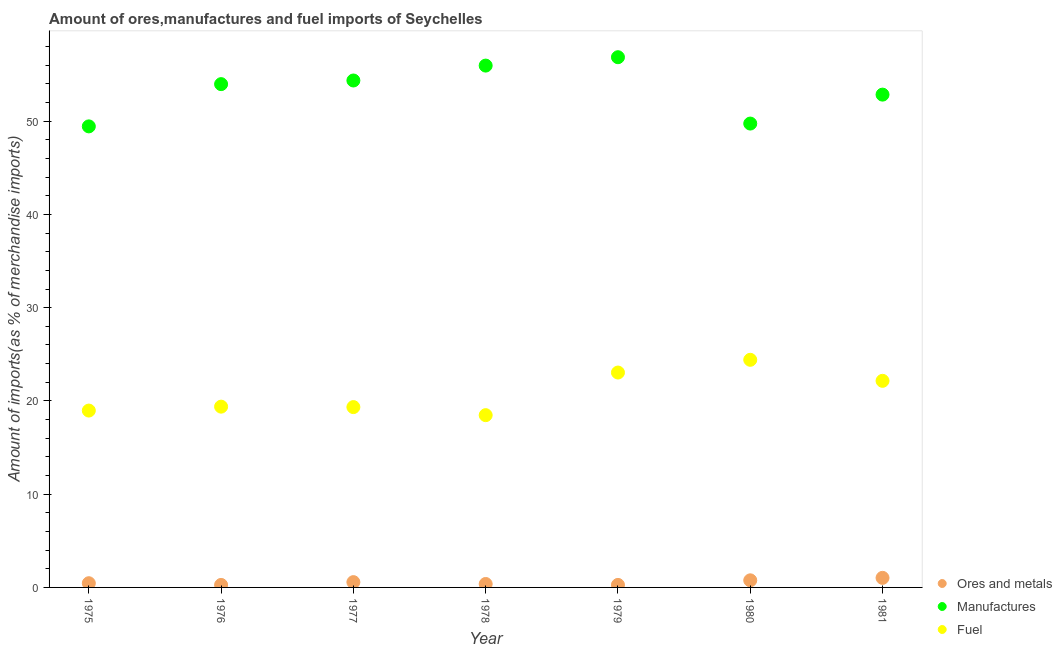What is the percentage of manufactures imports in 1976?
Ensure brevity in your answer.  53.97. Across all years, what is the maximum percentage of ores and metals imports?
Make the answer very short. 1.03. Across all years, what is the minimum percentage of ores and metals imports?
Ensure brevity in your answer.  0.27. In which year was the percentage of manufactures imports minimum?
Your answer should be very brief. 1975. What is the total percentage of manufactures imports in the graph?
Give a very brief answer. 373.18. What is the difference between the percentage of ores and metals imports in 1976 and that in 1978?
Your answer should be very brief. -0.1. What is the difference between the percentage of ores and metals imports in 1979 and the percentage of fuel imports in 1978?
Provide a short and direct response. -18.2. What is the average percentage of ores and metals imports per year?
Your answer should be very brief. 0.53. In the year 1976, what is the difference between the percentage of manufactures imports and percentage of fuel imports?
Provide a succinct answer. 34.59. In how many years, is the percentage of ores and metals imports greater than 22 %?
Keep it short and to the point. 0. What is the ratio of the percentage of fuel imports in 1975 to that in 1979?
Offer a terse response. 0.82. Is the percentage of ores and metals imports in 1975 less than that in 1981?
Your response must be concise. Yes. What is the difference between the highest and the second highest percentage of fuel imports?
Your answer should be very brief. 1.37. What is the difference between the highest and the lowest percentage of manufactures imports?
Ensure brevity in your answer.  7.42. Does the percentage of fuel imports monotonically increase over the years?
Your response must be concise. No. Does the graph contain any zero values?
Make the answer very short. No. Does the graph contain grids?
Your answer should be very brief. No. How are the legend labels stacked?
Give a very brief answer. Vertical. What is the title of the graph?
Ensure brevity in your answer.  Amount of ores,manufactures and fuel imports of Seychelles. Does "Liquid fuel" appear as one of the legend labels in the graph?
Ensure brevity in your answer.  No. What is the label or title of the Y-axis?
Offer a very short reply. Amount of imports(as % of merchandise imports). What is the Amount of imports(as % of merchandise imports) in Ores and metals in 1975?
Your answer should be compact. 0.45. What is the Amount of imports(as % of merchandise imports) of Manufactures in 1975?
Provide a succinct answer. 49.44. What is the Amount of imports(as % of merchandise imports) of Fuel in 1975?
Keep it short and to the point. 18.97. What is the Amount of imports(as % of merchandise imports) of Ores and metals in 1976?
Keep it short and to the point. 0.27. What is the Amount of imports(as % of merchandise imports) in Manufactures in 1976?
Make the answer very short. 53.97. What is the Amount of imports(as % of merchandise imports) of Fuel in 1976?
Offer a very short reply. 19.39. What is the Amount of imports(as % of merchandise imports) of Ores and metals in 1977?
Make the answer very short. 0.57. What is the Amount of imports(as % of merchandise imports) in Manufactures in 1977?
Keep it short and to the point. 54.36. What is the Amount of imports(as % of merchandise imports) of Fuel in 1977?
Provide a short and direct response. 19.34. What is the Amount of imports(as % of merchandise imports) in Ores and metals in 1978?
Make the answer very short. 0.37. What is the Amount of imports(as % of merchandise imports) in Manufactures in 1978?
Offer a very short reply. 55.96. What is the Amount of imports(as % of merchandise imports) in Fuel in 1978?
Provide a short and direct response. 18.47. What is the Amount of imports(as % of merchandise imports) in Ores and metals in 1979?
Offer a very short reply. 0.27. What is the Amount of imports(as % of merchandise imports) of Manufactures in 1979?
Provide a succinct answer. 56.86. What is the Amount of imports(as % of merchandise imports) in Fuel in 1979?
Provide a succinct answer. 23.04. What is the Amount of imports(as % of merchandise imports) of Ores and metals in 1980?
Your answer should be very brief. 0.76. What is the Amount of imports(as % of merchandise imports) of Manufactures in 1980?
Give a very brief answer. 49.74. What is the Amount of imports(as % of merchandise imports) in Fuel in 1980?
Ensure brevity in your answer.  24.41. What is the Amount of imports(as % of merchandise imports) of Ores and metals in 1981?
Offer a very short reply. 1.03. What is the Amount of imports(as % of merchandise imports) of Manufactures in 1981?
Ensure brevity in your answer.  52.85. What is the Amount of imports(as % of merchandise imports) of Fuel in 1981?
Give a very brief answer. 22.15. Across all years, what is the maximum Amount of imports(as % of merchandise imports) in Ores and metals?
Your response must be concise. 1.03. Across all years, what is the maximum Amount of imports(as % of merchandise imports) in Manufactures?
Make the answer very short. 56.86. Across all years, what is the maximum Amount of imports(as % of merchandise imports) of Fuel?
Your response must be concise. 24.41. Across all years, what is the minimum Amount of imports(as % of merchandise imports) in Ores and metals?
Your answer should be compact. 0.27. Across all years, what is the minimum Amount of imports(as % of merchandise imports) of Manufactures?
Your response must be concise. 49.44. Across all years, what is the minimum Amount of imports(as % of merchandise imports) in Fuel?
Ensure brevity in your answer.  18.47. What is the total Amount of imports(as % of merchandise imports) in Ores and metals in the graph?
Ensure brevity in your answer.  3.71. What is the total Amount of imports(as % of merchandise imports) of Manufactures in the graph?
Ensure brevity in your answer.  373.18. What is the total Amount of imports(as % of merchandise imports) in Fuel in the graph?
Offer a very short reply. 145.77. What is the difference between the Amount of imports(as % of merchandise imports) of Ores and metals in 1975 and that in 1976?
Make the answer very short. 0.18. What is the difference between the Amount of imports(as % of merchandise imports) of Manufactures in 1975 and that in 1976?
Your response must be concise. -4.53. What is the difference between the Amount of imports(as % of merchandise imports) of Fuel in 1975 and that in 1976?
Your response must be concise. -0.42. What is the difference between the Amount of imports(as % of merchandise imports) of Ores and metals in 1975 and that in 1977?
Provide a short and direct response. -0.11. What is the difference between the Amount of imports(as % of merchandise imports) in Manufactures in 1975 and that in 1977?
Ensure brevity in your answer.  -4.92. What is the difference between the Amount of imports(as % of merchandise imports) in Fuel in 1975 and that in 1977?
Keep it short and to the point. -0.37. What is the difference between the Amount of imports(as % of merchandise imports) of Ores and metals in 1975 and that in 1978?
Make the answer very short. 0.08. What is the difference between the Amount of imports(as % of merchandise imports) in Manufactures in 1975 and that in 1978?
Offer a terse response. -6.52. What is the difference between the Amount of imports(as % of merchandise imports) in Fuel in 1975 and that in 1978?
Make the answer very short. 0.49. What is the difference between the Amount of imports(as % of merchandise imports) of Ores and metals in 1975 and that in 1979?
Make the answer very short. 0.18. What is the difference between the Amount of imports(as % of merchandise imports) of Manufactures in 1975 and that in 1979?
Provide a short and direct response. -7.42. What is the difference between the Amount of imports(as % of merchandise imports) of Fuel in 1975 and that in 1979?
Your response must be concise. -4.08. What is the difference between the Amount of imports(as % of merchandise imports) in Ores and metals in 1975 and that in 1980?
Your answer should be compact. -0.31. What is the difference between the Amount of imports(as % of merchandise imports) in Manufactures in 1975 and that in 1980?
Your answer should be very brief. -0.3. What is the difference between the Amount of imports(as % of merchandise imports) in Fuel in 1975 and that in 1980?
Offer a terse response. -5.44. What is the difference between the Amount of imports(as % of merchandise imports) in Ores and metals in 1975 and that in 1981?
Offer a very short reply. -0.57. What is the difference between the Amount of imports(as % of merchandise imports) of Manufactures in 1975 and that in 1981?
Your answer should be very brief. -3.41. What is the difference between the Amount of imports(as % of merchandise imports) of Fuel in 1975 and that in 1981?
Offer a very short reply. -3.19. What is the difference between the Amount of imports(as % of merchandise imports) of Ores and metals in 1976 and that in 1977?
Offer a very short reply. -0.3. What is the difference between the Amount of imports(as % of merchandise imports) of Manufactures in 1976 and that in 1977?
Make the answer very short. -0.39. What is the difference between the Amount of imports(as % of merchandise imports) in Fuel in 1976 and that in 1977?
Your answer should be compact. 0.05. What is the difference between the Amount of imports(as % of merchandise imports) in Ores and metals in 1976 and that in 1978?
Ensure brevity in your answer.  -0.1. What is the difference between the Amount of imports(as % of merchandise imports) in Manufactures in 1976 and that in 1978?
Keep it short and to the point. -1.99. What is the difference between the Amount of imports(as % of merchandise imports) in Fuel in 1976 and that in 1978?
Offer a very short reply. 0.91. What is the difference between the Amount of imports(as % of merchandise imports) of Ores and metals in 1976 and that in 1979?
Your answer should be compact. -0. What is the difference between the Amount of imports(as % of merchandise imports) of Manufactures in 1976 and that in 1979?
Your response must be concise. -2.89. What is the difference between the Amount of imports(as % of merchandise imports) of Fuel in 1976 and that in 1979?
Offer a very short reply. -3.66. What is the difference between the Amount of imports(as % of merchandise imports) in Ores and metals in 1976 and that in 1980?
Offer a very short reply. -0.49. What is the difference between the Amount of imports(as % of merchandise imports) in Manufactures in 1976 and that in 1980?
Keep it short and to the point. 4.23. What is the difference between the Amount of imports(as % of merchandise imports) in Fuel in 1976 and that in 1980?
Provide a succinct answer. -5.02. What is the difference between the Amount of imports(as % of merchandise imports) in Ores and metals in 1976 and that in 1981?
Make the answer very short. -0.76. What is the difference between the Amount of imports(as % of merchandise imports) in Manufactures in 1976 and that in 1981?
Your response must be concise. 1.12. What is the difference between the Amount of imports(as % of merchandise imports) in Fuel in 1976 and that in 1981?
Ensure brevity in your answer.  -2.77. What is the difference between the Amount of imports(as % of merchandise imports) of Ores and metals in 1977 and that in 1978?
Your answer should be very brief. 0.2. What is the difference between the Amount of imports(as % of merchandise imports) in Manufactures in 1977 and that in 1978?
Your answer should be very brief. -1.6. What is the difference between the Amount of imports(as % of merchandise imports) of Fuel in 1977 and that in 1978?
Make the answer very short. 0.86. What is the difference between the Amount of imports(as % of merchandise imports) of Ores and metals in 1977 and that in 1979?
Give a very brief answer. 0.3. What is the difference between the Amount of imports(as % of merchandise imports) of Manufactures in 1977 and that in 1979?
Keep it short and to the point. -2.5. What is the difference between the Amount of imports(as % of merchandise imports) of Fuel in 1977 and that in 1979?
Your answer should be very brief. -3.71. What is the difference between the Amount of imports(as % of merchandise imports) of Ores and metals in 1977 and that in 1980?
Provide a succinct answer. -0.19. What is the difference between the Amount of imports(as % of merchandise imports) of Manufactures in 1977 and that in 1980?
Your answer should be very brief. 4.62. What is the difference between the Amount of imports(as % of merchandise imports) in Fuel in 1977 and that in 1980?
Offer a terse response. -5.07. What is the difference between the Amount of imports(as % of merchandise imports) of Ores and metals in 1977 and that in 1981?
Offer a terse response. -0.46. What is the difference between the Amount of imports(as % of merchandise imports) of Manufactures in 1977 and that in 1981?
Offer a very short reply. 1.52. What is the difference between the Amount of imports(as % of merchandise imports) in Fuel in 1977 and that in 1981?
Make the answer very short. -2.82. What is the difference between the Amount of imports(as % of merchandise imports) of Ores and metals in 1978 and that in 1979?
Give a very brief answer. 0.1. What is the difference between the Amount of imports(as % of merchandise imports) in Manufactures in 1978 and that in 1979?
Your answer should be compact. -0.9. What is the difference between the Amount of imports(as % of merchandise imports) in Fuel in 1978 and that in 1979?
Ensure brevity in your answer.  -4.57. What is the difference between the Amount of imports(as % of merchandise imports) of Ores and metals in 1978 and that in 1980?
Offer a very short reply. -0.39. What is the difference between the Amount of imports(as % of merchandise imports) in Manufactures in 1978 and that in 1980?
Ensure brevity in your answer.  6.22. What is the difference between the Amount of imports(as % of merchandise imports) in Fuel in 1978 and that in 1980?
Offer a very short reply. -5.94. What is the difference between the Amount of imports(as % of merchandise imports) of Ores and metals in 1978 and that in 1981?
Offer a very short reply. -0.66. What is the difference between the Amount of imports(as % of merchandise imports) in Manufactures in 1978 and that in 1981?
Make the answer very short. 3.11. What is the difference between the Amount of imports(as % of merchandise imports) in Fuel in 1978 and that in 1981?
Keep it short and to the point. -3.68. What is the difference between the Amount of imports(as % of merchandise imports) in Ores and metals in 1979 and that in 1980?
Keep it short and to the point. -0.49. What is the difference between the Amount of imports(as % of merchandise imports) of Manufactures in 1979 and that in 1980?
Ensure brevity in your answer.  7.12. What is the difference between the Amount of imports(as % of merchandise imports) of Fuel in 1979 and that in 1980?
Make the answer very short. -1.37. What is the difference between the Amount of imports(as % of merchandise imports) in Ores and metals in 1979 and that in 1981?
Offer a terse response. -0.76. What is the difference between the Amount of imports(as % of merchandise imports) in Manufactures in 1979 and that in 1981?
Provide a short and direct response. 4.01. What is the difference between the Amount of imports(as % of merchandise imports) of Fuel in 1979 and that in 1981?
Give a very brief answer. 0.89. What is the difference between the Amount of imports(as % of merchandise imports) of Ores and metals in 1980 and that in 1981?
Keep it short and to the point. -0.26. What is the difference between the Amount of imports(as % of merchandise imports) in Manufactures in 1980 and that in 1981?
Offer a terse response. -3.1. What is the difference between the Amount of imports(as % of merchandise imports) of Fuel in 1980 and that in 1981?
Your response must be concise. 2.26. What is the difference between the Amount of imports(as % of merchandise imports) in Ores and metals in 1975 and the Amount of imports(as % of merchandise imports) in Manufactures in 1976?
Give a very brief answer. -53.52. What is the difference between the Amount of imports(as % of merchandise imports) in Ores and metals in 1975 and the Amount of imports(as % of merchandise imports) in Fuel in 1976?
Provide a succinct answer. -18.93. What is the difference between the Amount of imports(as % of merchandise imports) in Manufactures in 1975 and the Amount of imports(as % of merchandise imports) in Fuel in 1976?
Your answer should be very brief. 30.06. What is the difference between the Amount of imports(as % of merchandise imports) of Ores and metals in 1975 and the Amount of imports(as % of merchandise imports) of Manufactures in 1977?
Your answer should be very brief. -53.91. What is the difference between the Amount of imports(as % of merchandise imports) of Ores and metals in 1975 and the Amount of imports(as % of merchandise imports) of Fuel in 1977?
Give a very brief answer. -18.89. What is the difference between the Amount of imports(as % of merchandise imports) in Manufactures in 1975 and the Amount of imports(as % of merchandise imports) in Fuel in 1977?
Ensure brevity in your answer.  30.1. What is the difference between the Amount of imports(as % of merchandise imports) in Ores and metals in 1975 and the Amount of imports(as % of merchandise imports) in Manufactures in 1978?
Provide a succinct answer. -55.51. What is the difference between the Amount of imports(as % of merchandise imports) in Ores and metals in 1975 and the Amount of imports(as % of merchandise imports) in Fuel in 1978?
Ensure brevity in your answer.  -18.02. What is the difference between the Amount of imports(as % of merchandise imports) in Manufactures in 1975 and the Amount of imports(as % of merchandise imports) in Fuel in 1978?
Ensure brevity in your answer.  30.97. What is the difference between the Amount of imports(as % of merchandise imports) in Ores and metals in 1975 and the Amount of imports(as % of merchandise imports) in Manufactures in 1979?
Give a very brief answer. -56.41. What is the difference between the Amount of imports(as % of merchandise imports) of Ores and metals in 1975 and the Amount of imports(as % of merchandise imports) of Fuel in 1979?
Your response must be concise. -22.59. What is the difference between the Amount of imports(as % of merchandise imports) in Manufactures in 1975 and the Amount of imports(as % of merchandise imports) in Fuel in 1979?
Your answer should be compact. 26.4. What is the difference between the Amount of imports(as % of merchandise imports) in Ores and metals in 1975 and the Amount of imports(as % of merchandise imports) in Manufactures in 1980?
Give a very brief answer. -49.29. What is the difference between the Amount of imports(as % of merchandise imports) of Ores and metals in 1975 and the Amount of imports(as % of merchandise imports) of Fuel in 1980?
Offer a terse response. -23.96. What is the difference between the Amount of imports(as % of merchandise imports) in Manufactures in 1975 and the Amount of imports(as % of merchandise imports) in Fuel in 1980?
Provide a succinct answer. 25.03. What is the difference between the Amount of imports(as % of merchandise imports) in Ores and metals in 1975 and the Amount of imports(as % of merchandise imports) in Manufactures in 1981?
Provide a short and direct response. -52.39. What is the difference between the Amount of imports(as % of merchandise imports) of Ores and metals in 1975 and the Amount of imports(as % of merchandise imports) of Fuel in 1981?
Give a very brief answer. -21.7. What is the difference between the Amount of imports(as % of merchandise imports) in Manufactures in 1975 and the Amount of imports(as % of merchandise imports) in Fuel in 1981?
Your answer should be compact. 27.29. What is the difference between the Amount of imports(as % of merchandise imports) of Ores and metals in 1976 and the Amount of imports(as % of merchandise imports) of Manufactures in 1977?
Your answer should be very brief. -54.09. What is the difference between the Amount of imports(as % of merchandise imports) in Ores and metals in 1976 and the Amount of imports(as % of merchandise imports) in Fuel in 1977?
Your answer should be compact. -19.07. What is the difference between the Amount of imports(as % of merchandise imports) of Manufactures in 1976 and the Amount of imports(as % of merchandise imports) of Fuel in 1977?
Keep it short and to the point. 34.63. What is the difference between the Amount of imports(as % of merchandise imports) of Ores and metals in 1976 and the Amount of imports(as % of merchandise imports) of Manufactures in 1978?
Offer a terse response. -55.69. What is the difference between the Amount of imports(as % of merchandise imports) in Ores and metals in 1976 and the Amount of imports(as % of merchandise imports) in Fuel in 1978?
Offer a very short reply. -18.21. What is the difference between the Amount of imports(as % of merchandise imports) of Manufactures in 1976 and the Amount of imports(as % of merchandise imports) of Fuel in 1978?
Keep it short and to the point. 35.5. What is the difference between the Amount of imports(as % of merchandise imports) in Ores and metals in 1976 and the Amount of imports(as % of merchandise imports) in Manufactures in 1979?
Offer a very short reply. -56.59. What is the difference between the Amount of imports(as % of merchandise imports) in Ores and metals in 1976 and the Amount of imports(as % of merchandise imports) in Fuel in 1979?
Provide a short and direct response. -22.78. What is the difference between the Amount of imports(as % of merchandise imports) in Manufactures in 1976 and the Amount of imports(as % of merchandise imports) in Fuel in 1979?
Your answer should be very brief. 30.93. What is the difference between the Amount of imports(as % of merchandise imports) in Ores and metals in 1976 and the Amount of imports(as % of merchandise imports) in Manufactures in 1980?
Your response must be concise. -49.47. What is the difference between the Amount of imports(as % of merchandise imports) of Ores and metals in 1976 and the Amount of imports(as % of merchandise imports) of Fuel in 1980?
Your answer should be very brief. -24.14. What is the difference between the Amount of imports(as % of merchandise imports) of Manufactures in 1976 and the Amount of imports(as % of merchandise imports) of Fuel in 1980?
Your answer should be compact. 29.56. What is the difference between the Amount of imports(as % of merchandise imports) of Ores and metals in 1976 and the Amount of imports(as % of merchandise imports) of Manufactures in 1981?
Make the answer very short. -52.58. What is the difference between the Amount of imports(as % of merchandise imports) of Ores and metals in 1976 and the Amount of imports(as % of merchandise imports) of Fuel in 1981?
Your response must be concise. -21.89. What is the difference between the Amount of imports(as % of merchandise imports) of Manufactures in 1976 and the Amount of imports(as % of merchandise imports) of Fuel in 1981?
Provide a succinct answer. 31.82. What is the difference between the Amount of imports(as % of merchandise imports) of Ores and metals in 1977 and the Amount of imports(as % of merchandise imports) of Manufactures in 1978?
Your answer should be compact. -55.39. What is the difference between the Amount of imports(as % of merchandise imports) in Ores and metals in 1977 and the Amount of imports(as % of merchandise imports) in Fuel in 1978?
Offer a terse response. -17.91. What is the difference between the Amount of imports(as % of merchandise imports) in Manufactures in 1977 and the Amount of imports(as % of merchandise imports) in Fuel in 1978?
Offer a terse response. 35.89. What is the difference between the Amount of imports(as % of merchandise imports) of Ores and metals in 1977 and the Amount of imports(as % of merchandise imports) of Manufactures in 1979?
Offer a very short reply. -56.29. What is the difference between the Amount of imports(as % of merchandise imports) of Ores and metals in 1977 and the Amount of imports(as % of merchandise imports) of Fuel in 1979?
Make the answer very short. -22.48. What is the difference between the Amount of imports(as % of merchandise imports) of Manufactures in 1977 and the Amount of imports(as % of merchandise imports) of Fuel in 1979?
Offer a terse response. 31.32. What is the difference between the Amount of imports(as % of merchandise imports) in Ores and metals in 1977 and the Amount of imports(as % of merchandise imports) in Manufactures in 1980?
Offer a very short reply. -49.18. What is the difference between the Amount of imports(as % of merchandise imports) in Ores and metals in 1977 and the Amount of imports(as % of merchandise imports) in Fuel in 1980?
Your answer should be very brief. -23.84. What is the difference between the Amount of imports(as % of merchandise imports) of Manufactures in 1977 and the Amount of imports(as % of merchandise imports) of Fuel in 1980?
Ensure brevity in your answer.  29.95. What is the difference between the Amount of imports(as % of merchandise imports) of Ores and metals in 1977 and the Amount of imports(as % of merchandise imports) of Manufactures in 1981?
Your answer should be compact. -52.28. What is the difference between the Amount of imports(as % of merchandise imports) of Ores and metals in 1977 and the Amount of imports(as % of merchandise imports) of Fuel in 1981?
Keep it short and to the point. -21.59. What is the difference between the Amount of imports(as % of merchandise imports) in Manufactures in 1977 and the Amount of imports(as % of merchandise imports) in Fuel in 1981?
Ensure brevity in your answer.  32.21. What is the difference between the Amount of imports(as % of merchandise imports) in Ores and metals in 1978 and the Amount of imports(as % of merchandise imports) in Manufactures in 1979?
Provide a short and direct response. -56.49. What is the difference between the Amount of imports(as % of merchandise imports) of Ores and metals in 1978 and the Amount of imports(as % of merchandise imports) of Fuel in 1979?
Offer a very short reply. -22.68. What is the difference between the Amount of imports(as % of merchandise imports) in Manufactures in 1978 and the Amount of imports(as % of merchandise imports) in Fuel in 1979?
Give a very brief answer. 32.92. What is the difference between the Amount of imports(as % of merchandise imports) in Ores and metals in 1978 and the Amount of imports(as % of merchandise imports) in Manufactures in 1980?
Ensure brevity in your answer.  -49.37. What is the difference between the Amount of imports(as % of merchandise imports) in Ores and metals in 1978 and the Amount of imports(as % of merchandise imports) in Fuel in 1980?
Offer a very short reply. -24.04. What is the difference between the Amount of imports(as % of merchandise imports) in Manufactures in 1978 and the Amount of imports(as % of merchandise imports) in Fuel in 1980?
Ensure brevity in your answer.  31.55. What is the difference between the Amount of imports(as % of merchandise imports) of Ores and metals in 1978 and the Amount of imports(as % of merchandise imports) of Manufactures in 1981?
Offer a very short reply. -52.48. What is the difference between the Amount of imports(as % of merchandise imports) in Ores and metals in 1978 and the Amount of imports(as % of merchandise imports) in Fuel in 1981?
Your answer should be very brief. -21.79. What is the difference between the Amount of imports(as % of merchandise imports) of Manufactures in 1978 and the Amount of imports(as % of merchandise imports) of Fuel in 1981?
Your response must be concise. 33.81. What is the difference between the Amount of imports(as % of merchandise imports) in Ores and metals in 1979 and the Amount of imports(as % of merchandise imports) in Manufactures in 1980?
Offer a terse response. -49.47. What is the difference between the Amount of imports(as % of merchandise imports) of Ores and metals in 1979 and the Amount of imports(as % of merchandise imports) of Fuel in 1980?
Make the answer very short. -24.14. What is the difference between the Amount of imports(as % of merchandise imports) in Manufactures in 1979 and the Amount of imports(as % of merchandise imports) in Fuel in 1980?
Offer a very short reply. 32.45. What is the difference between the Amount of imports(as % of merchandise imports) of Ores and metals in 1979 and the Amount of imports(as % of merchandise imports) of Manufactures in 1981?
Your answer should be very brief. -52.58. What is the difference between the Amount of imports(as % of merchandise imports) of Ores and metals in 1979 and the Amount of imports(as % of merchandise imports) of Fuel in 1981?
Make the answer very short. -21.88. What is the difference between the Amount of imports(as % of merchandise imports) of Manufactures in 1979 and the Amount of imports(as % of merchandise imports) of Fuel in 1981?
Your answer should be very brief. 34.7. What is the difference between the Amount of imports(as % of merchandise imports) of Ores and metals in 1980 and the Amount of imports(as % of merchandise imports) of Manufactures in 1981?
Offer a terse response. -52.09. What is the difference between the Amount of imports(as % of merchandise imports) of Ores and metals in 1980 and the Amount of imports(as % of merchandise imports) of Fuel in 1981?
Ensure brevity in your answer.  -21.39. What is the difference between the Amount of imports(as % of merchandise imports) of Manufactures in 1980 and the Amount of imports(as % of merchandise imports) of Fuel in 1981?
Offer a very short reply. 27.59. What is the average Amount of imports(as % of merchandise imports) in Ores and metals per year?
Offer a terse response. 0.53. What is the average Amount of imports(as % of merchandise imports) of Manufactures per year?
Your answer should be compact. 53.31. What is the average Amount of imports(as % of merchandise imports) in Fuel per year?
Your answer should be very brief. 20.82. In the year 1975, what is the difference between the Amount of imports(as % of merchandise imports) of Ores and metals and Amount of imports(as % of merchandise imports) of Manufactures?
Your answer should be very brief. -48.99. In the year 1975, what is the difference between the Amount of imports(as % of merchandise imports) in Ores and metals and Amount of imports(as % of merchandise imports) in Fuel?
Ensure brevity in your answer.  -18.51. In the year 1975, what is the difference between the Amount of imports(as % of merchandise imports) in Manufactures and Amount of imports(as % of merchandise imports) in Fuel?
Provide a succinct answer. 30.48. In the year 1976, what is the difference between the Amount of imports(as % of merchandise imports) in Ores and metals and Amount of imports(as % of merchandise imports) in Manufactures?
Your answer should be very brief. -53.7. In the year 1976, what is the difference between the Amount of imports(as % of merchandise imports) in Ores and metals and Amount of imports(as % of merchandise imports) in Fuel?
Offer a terse response. -19.12. In the year 1976, what is the difference between the Amount of imports(as % of merchandise imports) of Manufactures and Amount of imports(as % of merchandise imports) of Fuel?
Offer a terse response. 34.59. In the year 1977, what is the difference between the Amount of imports(as % of merchandise imports) in Ores and metals and Amount of imports(as % of merchandise imports) in Manufactures?
Your answer should be compact. -53.8. In the year 1977, what is the difference between the Amount of imports(as % of merchandise imports) of Ores and metals and Amount of imports(as % of merchandise imports) of Fuel?
Your response must be concise. -18.77. In the year 1977, what is the difference between the Amount of imports(as % of merchandise imports) in Manufactures and Amount of imports(as % of merchandise imports) in Fuel?
Provide a succinct answer. 35.02. In the year 1978, what is the difference between the Amount of imports(as % of merchandise imports) in Ores and metals and Amount of imports(as % of merchandise imports) in Manufactures?
Make the answer very short. -55.59. In the year 1978, what is the difference between the Amount of imports(as % of merchandise imports) in Ores and metals and Amount of imports(as % of merchandise imports) in Fuel?
Offer a very short reply. -18.1. In the year 1978, what is the difference between the Amount of imports(as % of merchandise imports) of Manufactures and Amount of imports(as % of merchandise imports) of Fuel?
Offer a very short reply. 37.49. In the year 1979, what is the difference between the Amount of imports(as % of merchandise imports) of Ores and metals and Amount of imports(as % of merchandise imports) of Manufactures?
Keep it short and to the point. -56.59. In the year 1979, what is the difference between the Amount of imports(as % of merchandise imports) in Ores and metals and Amount of imports(as % of merchandise imports) in Fuel?
Your answer should be compact. -22.77. In the year 1979, what is the difference between the Amount of imports(as % of merchandise imports) in Manufactures and Amount of imports(as % of merchandise imports) in Fuel?
Offer a terse response. 33.81. In the year 1980, what is the difference between the Amount of imports(as % of merchandise imports) of Ores and metals and Amount of imports(as % of merchandise imports) of Manufactures?
Your response must be concise. -48.98. In the year 1980, what is the difference between the Amount of imports(as % of merchandise imports) of Ores and metals and Amount of imports(as % of merchandise imports) of Fuel?
Your answer should be very brief. -23.65. In the year 1980, what is the difference between the Amount of imports(as % of merchandise imports) of Manufactures and Amount of imports(as % of merchandise imports) of Fuel?
Keep it short and to the point. 25.33. In the year 1981, what is the difference between the Amount of imports(as % of merchandise imports) in Ores and metals and Amount of imports(as % of merchandise imports) in Manufactures?
Make the answer very short. -51.82. In the year 1981, what is the difference between the Amount of imports(as % of merchandise imports) in Ores and metals and Amount of imports(as % of merchandise imports) in Fuel?
Offer a very short reply. -21.13. In the year 1981, what is the difference between the Amount of imports(as % of merchandise imports) of Manufactures and Amount of imports(as % of merchandise imports) of Fuel?
Provide a succinct answer. 30.69. What is the ratio of the Amount of imports(as % of merchandise imports) in Ores and metals in 1975 to that in 1976?
Your answer should be very brief. 1.69. What is the ratio of the Amount of imports(as % of merchandise imports) of Manufactures in 1975 to that in 1976?
Your answer should be very brief. 0.92. What is the ratio of the Amount of imports(as % of merchandise imports) of Fuel in 1975 to that in 1976?
Give a very brief answer. 0.98. What is the ratio of the Amount of imports(as % of merchandise imports) in Ores and metals in 1975 to that in 1977?
Provide a succinct answer. 0.8. What is the ratio of the Amount of imports(as % of merchandise imports) in Manufactures in 1975 to that in 1977?
Ensure brevity in your answer.  0.91. What is the ratio of the Amount of imports(as % of merchandise imports) in Fuel in 1975 to that in 1977?
Offer a terse response. 0.98. What is the ratio of the Amount of imports(as % of merchandise imports) of Ores and metals in 1975 to that in 1978?
Your response must be concise. 1.23. What is the ratio of the Amount of imports(as % of merchandise imports) in Manufactures in 1975 to that in 1978?
Provide a short and direct response. 0.88. What is the ratio of the Amount of imports(as % of merchandise imports) of Fuel in 1975 to that in 1978?
Your answer should be very brief. 1.03. What is the ratio of the Amount of imports(as % of merchandise imports) of Ores and metals in 1975 to that in 1979?
Make the answer very short. 1.68. What is the ratio of the Amount of imports(as % of merchandise imports) of Manufactures in 1975 to that in 1979?
Make the answer very short. 0.87. What is the ratio of the Amount of imports(as % of merchandise imports) of Fuel in 1975 to that in 1979?
Provide a succinct answer. 0.82. What is the ratio of the Amount of imports(as % of merchandise imports) of Ores and metals in 1975 to that in 1980?
Provide a succinct answer. 0.59. What is the ratio of the Amount of imports(as % of merchandise imports) in Manufactures in 1975 to that in 1980?
Offer a terse response. 0.99. What is the ratio of the Amount of imports(as % of merchandise imports) of Fuel in 1975 to that in 1980?
Ensure brevity in your answer.  0.78. What is the ratio of the Amount of imports(as % of merchandise imports) of Ores and metals in 1975 to that in 1981?
Offer a terse response. 0.44. What is the ratio of the Amount of imports(as % of merchandise imports) in Manufactures in 1975 to that in 1981?
Ensure brevity in your answer.  0.94. What is the ratio of the Amount of imports(as % of merchandise imports) of Fuel in 1975 to that in 1981?
Provide a succinct answer. 0.86. What is the ratio of the Amount of imports(as % of merchandise imports) in Ores and metals in 1976 to that in 1977?
Provide a succinct answer. 0.47. What is the ratio of the Amount of imports(as % of merchandise imports) of Manufactures in 1976 to that in 1977?
Your answer should be compact. 0.99. What is the ratio of the Amount of imports(as % of merchandise imports) in Fuel in 1976 to that in 1977?
Offer a terse response. 1. What is the ratio of the Amount of imports(as % of merchandise imports) of Ores and metals in 1976 to that in 1978?
Offer a terse response. 0.73. What is the ratio of the Amount of imports(as % of merchandise imports) in Manufactures in 1976 to that in 1978?
Ensure brevity in your answer.  0.96. What is the ratio of the Amount of imports(as % of merchandise imports) of Fuel in 1976 to that in 1978?
Your response must be concise. 1.05. What is the ratio of the Amount of imports(as % of merchandise imports) in Manufactures in 1976 to that in 1979?
Offer a terse response. 0.95. What is the ratio of the Amount of imports(as % of merchandise imports) of Fuel in 1976 to that in 1979?
Provide a short and direct response. 0.84. What is the ratio of the Amount of imports(as % of merchandise imports) in Ores and metals in 1976 to that in 1980?
Ensure brevity in your answer.  0.35. What is the ratio of the Amount of imports(as % of merchandise imports) of Manufactures in 1976 to that in 1980?
Offer a terse response. 1.08. What is the ratio of the Amount of imports(as % of merchandise imports) of Fuel in 1976 to that in 1980?
Provide a short and direct response. 0.79. What is the ratio of the Amount of imports(as % of merchandise imports) of Ores and metals in 1976 to that in 1981?
Your answer should be compact. 0.26. What is the ratio of the Amount of imports(as % of merchandise imports) in Manufactures in 1976 to that in 1981?
Make the answer very short. 1.02. What is the ratio of the Amount of imports(as % of merchandise imports) of Ores and metals in 1977 to that in 1978?
Offer a very short reply. 1.54. What is the ratio of the Amount of imports(as % of merchandise imports) of Manufactures in 1977 to that in 1978?
Provide a succinct answer. 0.97. What is the ratio of the Amount of imports(as % of merchandise imports) of Fuel in 1977 to that in 1978?
Provide a succinct answer. 1.05. What is the ratio of the Amount of imports(as % of merchandise imports) in Ores and metals in 1977 to that in 1979?
Offer a very short reply. 2.1. What is the ratio of the Amount of imports(as % of merchandise imports) of Manufactures in 1977 to that in 1979?
Your answer should be very brief. 0.96. What is the ratio of the Amount of imports(as % of merchandise imports) of Fuel in 1977 to that in 1979?
Offer a terse response. 0.84. What is the ratio of the Amount of imports(as % of merchandise imports) in Ores and metals in 1977 to that in 1980?
Offer a very short reply. 0.74. What is the ratio of the Amount of imports(as % of merchandise imports) of Manufactures in 1977 to that in 1980?
Your answer should be compact. 1.09. What is the ratio of the Amount of imports(as % of merchandise imports) of Fuel in 1977 to that in 1980?
Offer a very short reply. 0.79. What is the ratio of the Amount of imports(as % of merchandise imports) in Ores and metals in 1977 to that in 1981?
Offer a very short reply. 0.55. What is the ratio of the Amount of imports(as % of merchandise imports) of Manufactures in 1977 to that in 1981?
Provide a short and direct response. 1.03. What is the ratio of the Amount of imports(as % of merchandise imports) of Fuel in 1977 to that in 1981?
Ensure brevity in your answer.  0.87. What is the ratio of the Amount of imports(as % of merchandise imports) of Ores and metals in 1978 to that in 1979?
Your answer should be very brief. 1.37. What is the ratio of the Amount of imports(as % of merchandise imports) of Manufactures in 1978 to that in 1979?
Ensure brevity in your answer.  0.98. What is the ratio of the Amount of imports(as % of merchandise imports) of Fuel in 1978 to that in 1979?
Make the answer very short. 0.8. What is the ratio of the Amount of imports(as % of merchandise imports) in Ores and metals in 1978 to that in 1980?
Offer a very short reply. 0.48. What is the ratio of the Amount of imports(as % of merchandise imports) of Manufactures in 1978 to that in 1980?
Give a very brief answer. 1.12. What is the ratio of the Amount of imports(as % of merchandise imports) in Fuel in 1978 to that in 1980?
Give a very brief answer. 0.76. What is the ratio of the Amount of imports(as % of merchandise imports) in Ores and metals in 1978 to that in 1981?
Offer a terse response. 0.36. What is the ratio of the Amount of imports(as % of merchandise imports) of Manufactures in 1978 to that in 1981?
Offer a terse response. 1.06. What is the ratio of the Amount of imports(as % of merchandise imports) in Fuel in 1978 to that in 1981?
Keep it short and to the point. 0.83. What is the ratio of the Amount of imports(as % of merchandise imports) in Ores and metals in 1979 to that in 1980?
Ensure brevity in your answer.  0.35. What is the ratio of the Amount of imports(as % of merchandise imports) of Manufactures in 1979 to that in 1980?
Keep it short and to the point. 1.14. What is the ratio of the Amount of imports(as % of merchandise imports) of Fuel in 1979 to that in 1980?
Your response must be concise. 0.94. What is the ratio of the Amount of imports(as % of merchandise imports) in Ores and metals in 1979 to that in 1981?
Offer a terse response. 0.26. What is the ratio of the Amount of imports(as % of merchandise imports) in Manufactures in 1979 to that in 1981?
Your answer should be compact. 1.08. What is the ratio of the Amount of imports(as % of merchandise imports) of Fuel in 1979 to that in 1981?
Make the answer very short. 1.04. What is the ratio of the Amount of imports(as % of merchandise imports) in Ores and metals in 1980 to that in 1981?
Offer a very short reply. 0.74. What is the ratio of the Amount of imports(as % of merchandise imports) of Manufactures in 1980 to that in 1981?
Make the answer very short. 0.94. What is the ratio of the Amount of imports(as % of merchandise imports) in Fuel in 1980 to that in 1981?
Your response must be concise. 1.1. What is the difference between the highest and the second highest Amount of imports(as % of merchandise imports) in Ores and metals?
Your answer should be very brief. 0.26. What is the difference between the highest and the second highest Amount of imports(as % of merchandise imports) of Manufactures?
Give a very brief answer. 0.9. What is the difference between the highest and the second highest Amount of imports(as % of merchandise imports) of Fuel?
Your answer should be compact. 1.37. What is the difference between the highest and the lowest Amount of imports(as % of merchandise imports) in Ores and metals?
Your response must be concise. 0.76. What is the difference between the highest and the lowest Amount of imports(as % of merchandise imports) of Manufactures?
Give a very brief answer. 7.42. What is the difference between the highest and the lowest Amount of imports(as % of merchandise imports) in Fuel?
Offer a very short reply. 5.94. 